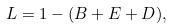<formula> <loc_0><loc_0><loc_500><loc_500>L = 1 - ( B + E + D ) ,</formula> 